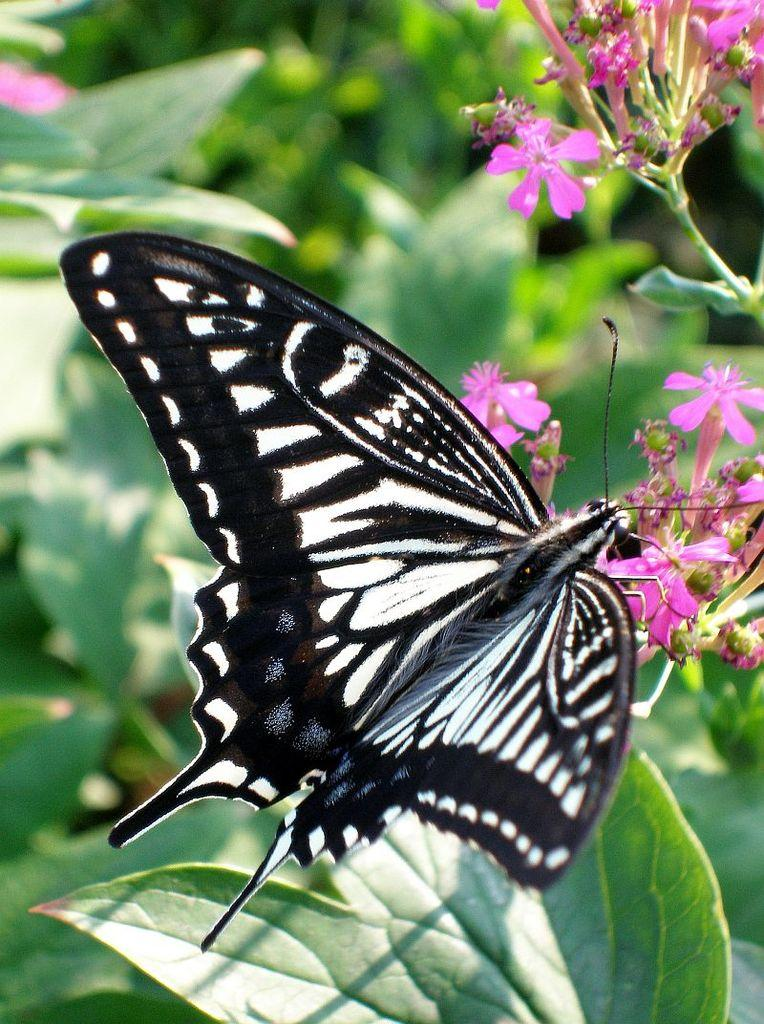What type of insect is present in the image? There is a butterfly in the image. What other natural elements can be seen in the image? There are flowers, buds, and green leaves in the image. What is the color of the leaves in the image? The leaves in the image are green. How would you describe the background of the image? The background of the image is blurred and green. What type of trouble is the butterfly causing in the image? There is no indication of trouble in the image; the butterfly is simply present among the flowers and leaves. 